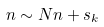<formula> <loc_0><loc_0><loc_500><loc_500>n \sim N n + s _ { k }</formula> 